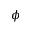<formula> <loc_0><loc_0><loc_500><loc_500>\phi</formula> 